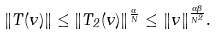Convert formula to latex. <formula><loc_0><loc_0><loc_500><loc_500>\| T ( v ) \| \leq \| T _ { 2 } ( v ) \| ^ { \frac { \alpha } { N } } \leq \| v \| ^ { \frac { \alpha \beta } { N ^ { 2 } } } .</formula> 